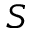Convert formula to latex. <formula><loc_0><loc_0><loc_500><loc_500>S</formula> 